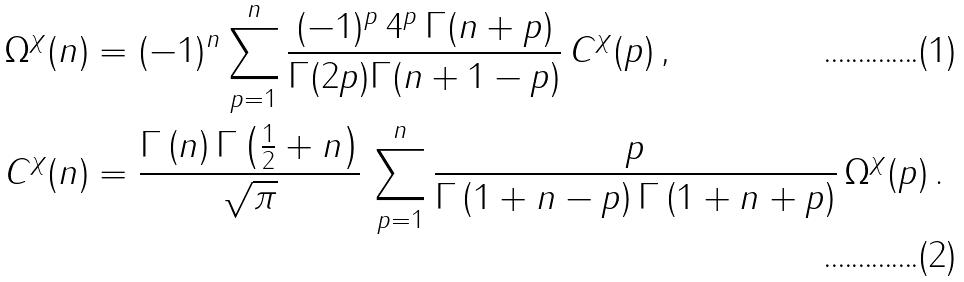Convert formula to latex. <formula><loc_0><loc_0><loc_500><loc_500>\Omega ^ { \chi } ( n ) & = ( - 1 ) ^ { n } \sum _ { p = 1 } ^ { n } \frac { ( - 1 ) ^ { p } \, 4 ^ { p } \, \Gamma ( n + p ) } { \Gamma ( 2 p ) \Gamma ( n + 1 - p ) } \, C ^ { \chi } ( p ) \, , \\ C ^ { \chi } ( n ) & = \frac { \Gamma \left ( n \right ) \Gamma \left ( \frac { 1 } { 2 } + n \right ) } { \sqrt { \pi } } \, \sum _ { p = 1 } ^ { n } \frac { p } { \Gamma \left ( 1 + n - p \right ) \Gamma \left ( 1 + n + p \right ) } \, \Omega ^ { \chi } ( p ) \, .</formula> 